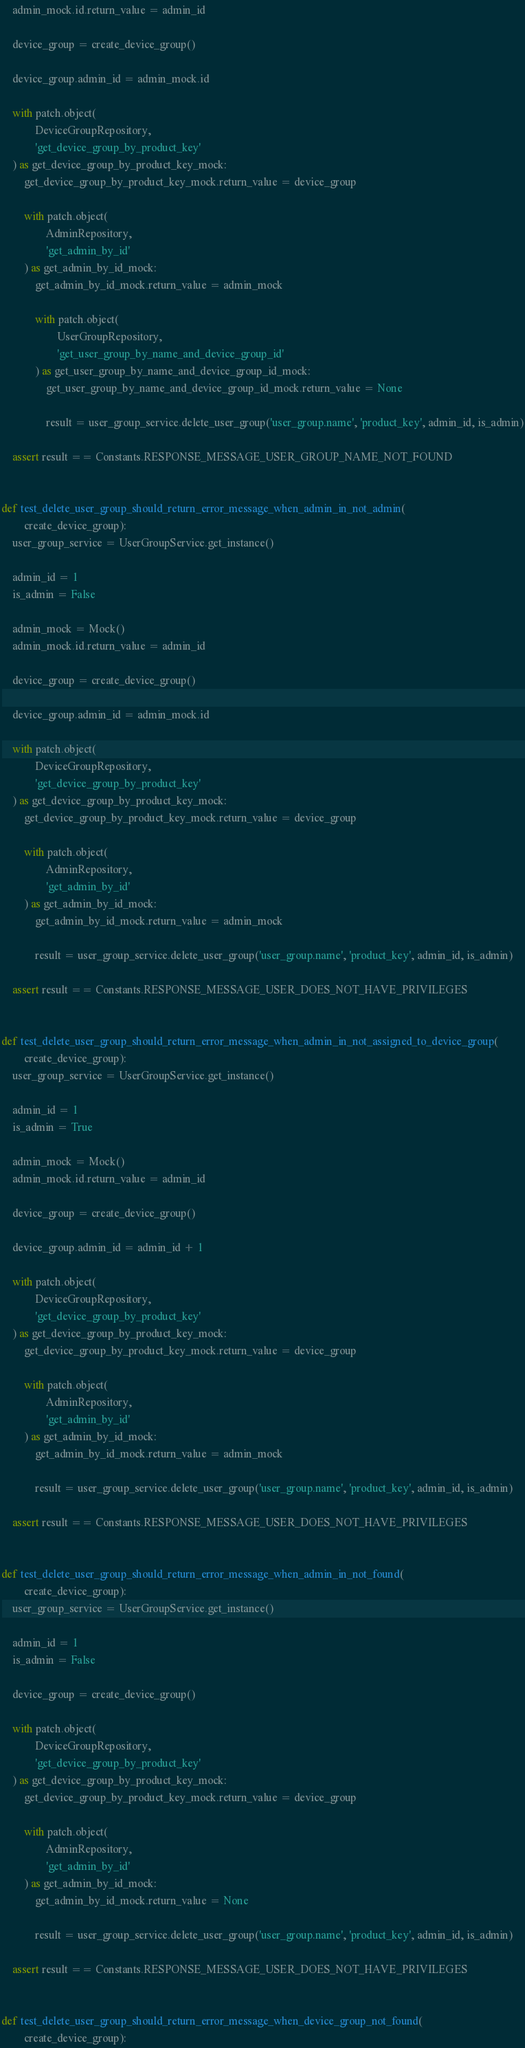Convert code to text. <code><loc_0><loc_0><loc_500><loc_500><_Python_>    admin_mock.id.return_value = admin_id

    device_group = create_device_group()

    device_group.admin_id = admin_mock.id

    with patch.object(
            DeviceGroupRepository,
            'get_device_group_by_product_key'
    ) as get_device_group_by_product_key_mock:
        get_device_group_by_product_key_mock.return_value = device_group

        with patch.object(
                AdminRepository,
                'get_admin_by_id'
        ) as get_admin_by_id_mock:
            get_admin_by_id_mock.return_value = admin_mock

            with patch.object(
                    UserGroupRepository,
                    'get_user_group_by_name_and_device_group_id'
            ) as get_user_group_by_name_and_device_group_id_mock:
                get_user_group_by_name_and_device_group_id_mock.return_value = None

                result = user_group_service.delete_user_group('user_group.name', 'product_key', admin_id, is_admin)

    assert result == Constants.RESPONSE_MESSAGE_USER_GROUP_NAME_NOT_FOUND


def test_delete_user_group_should_return_error_message_when_admin_in_not_admin(
        create_device_group):
    user_group_service = UserGroupService.get_instance()

    admin_id = 1
    is_admin = False

    admin_mock = Mock()
    admin_mock.id.return_value = admin_id

    device_group = create_device_group()

    device_group.admin_id = admin_mock.id

    with patch.object(
            DeviceGroupRepository,
            'get_device_group_by_product_key'
    ) as get_device_group_by_product_key_mock:
        get_device_group_by_product_key_mock.return_value = device_group

        with patch.object(
                AdminRepository,
                'get_admin_by_id'
        ) as get_admin_by_id_mock:
            get_admin_by_id_mock.return_value = admin_mock

            result = user_group_service.delete_user_group('user_group.name', 'product_key', admin_id, is_admin)

    assert result == Constants.RESPONSE_MESSAGE_USER_DOES_NOT_HAVE_PRIVILEGES


def test_delete_user_group_should_return_error_message_when_admin_in_not_assigned_to_device_group(
        create_device_group):
    user_group_service = UserGroupService.get_instance()

    admin_id = 1
    is_admin = True

    admin_mock = Mock()
    admin_mock.id.return_value = admin_id

    device_group = create_device_group()

    device_group.admin_id = admin_id + 1

    with patch.object(
            DeviceGroupRepository,
            'get_device_group_by_product_key'
    ) as get_device_group_by_product_key_mock:
        get_device_group_by_product_key_mock.return_value = device_group

        with patch.object(
                AdminRepository,
                'get_admin_by_id'
        ) as get_admin_by_id_mock:
            get_admin_by_id_mock.return_value = admin_mock

            result = user_group_service.delete_user_group('user_group.name', 'product_key', admin_id, is_admin)

    assert result == Constants.RESPONSE_MESSAGE_USER_DOES_NOT_HAVE_PRIVILEGES


def test_delete_user_group_should_return_error_message_when_admin_in_not_found(
        create_device_group):
    user_group_service = UserGroupService.get_instance()

    admin_id = 1
    is_admin = False

    device_group = create_device_group()

    with patch.object(
            DeviceGroupRepository,
            'get_device_group_by_product_key'
    ) as get_device_group_by_product_key_mock:
        get_device_group_by_product_key_mock.return_value = device_group

        with patch.object(
                AdminRepository,
                'get_admin_by_id'
        ) as get_admin_by_id_mock:
            get_admin_by_id_mock.return_value = None

            result = user_group_service.delete_user_group('user_group.name', 'product_key', admin_id, is_admin)

    assert result == Constants.RESPONSE_MESSAGE_USER_DOES_NOT_HAVE_PRIVILEGES


def test_delete_user_group_should_return_error_message_when_device_group_not_found(
        create_device_group):</code> 